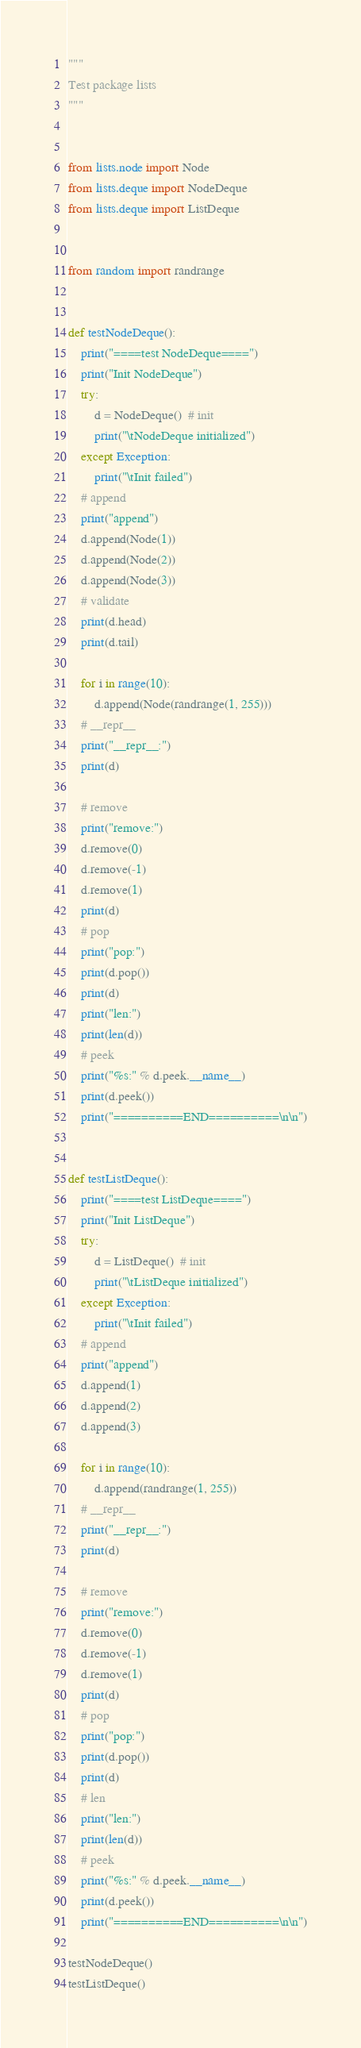Convert code to text. <code><loc_0><loc_0><loc_500><loc_500><_Python_>"""
Test package lists
"""


from lists.node import Node
from lists.deque import NodeDeque
from lists.deque import ListDeque


from random import randrange


def testNodeDeque():
    print("====test NodeDeque====")
    print("Init NodeDeque")
    try:
        d = NodeDeque()  # init
        print("\tNodeDeque initialized")
    except Exception:
        print("\tInit failed")
    # append
    print("append")
    d.append(Node(1))
    d.append(Node(2))
    d.append(Node(3))
    # validate
    print(d.head)
    print(d.tail)

    for i in range(10):
        d.append(Node(randrange(1, 255)))
    # __repr__
    print("__repr__:")
    print(d)

    # remove
    print("remove:")
    d.remove(0)
    d.remove(-1)
    d.remove(1)
    print(d)
    # pop
    print("pop:")
    print(d.pop())
    print(d)
    print("len:")
    print(len(d))  
    # peek 
    print("%s:" % d.peek.__name__)
    print(d.peek())  
    print("==========END==========\n\n")


def testListDeque():
    print("====test ListDeque====")
    print("Init ListDeque")
    try:
        d = ListDeque()  # init
        print("\tListDeque initialized")
    except Exception:
        print("\tInit failed")
    # append
    print("append")
    d.append(1)
    d.append(2)
    d.append(3)

    for i in range(10):
        d.append(randrange(1, 255))
    # __repr__
    print("__repr__:")
    print(d)

    # remove
    print("remove:")
    d.remove(0)
    d.remove(-1)
    d.remove(1)
    print(d)
    # pop
    print("pop:")
    print(d.pop())
    print(d)
    # len
    print("len:")
    print(len(d))
    # peek 
    print("%s:" % d.peek.__name__)
    print(d.peek())
    print("==========END==========\n\n")

testNodeDeque()
testListDeque()
</code> 